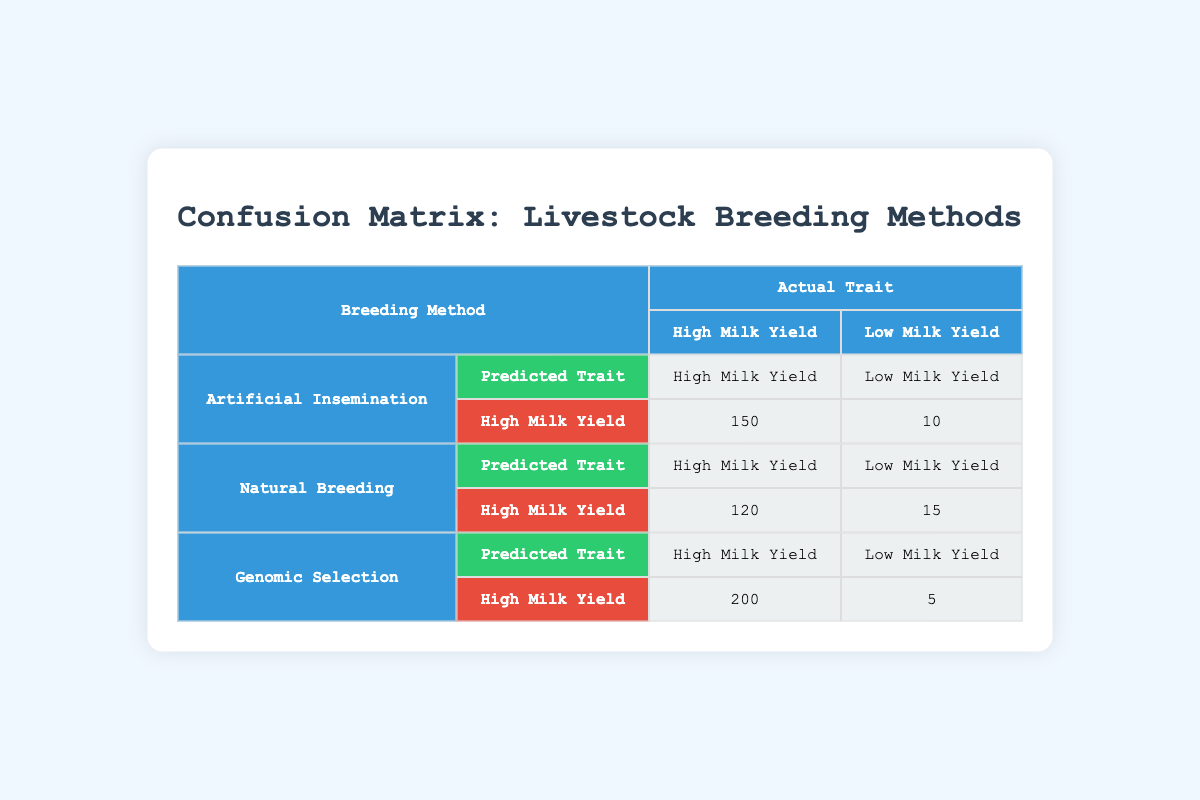What is the predicted trait count for High Milk Yield from Genomic Selection? From the table, under Genomic Selection with predicted trait as High Milk Yield, the count is given as 200.
Answer: 200 How many actual Low Milk Yield traits were predicted as High Milk Yield by Natural Breeding? The table shows that Natural Breeding predicted High Milk Yield for 15 actual Low Milk Yield cases.
Answer: 15 What is the total count of predicted High Milk Yield traits across all breeding methods? Adding the predicted High Milk Yield counts from all methods gives: 150 (AI) + 120 (Natural Breeding) + 200 (Genomic Selection) = 470.
Answer: 470 Is it true that Artificial Insemination had more Low Milk Yield predictions than Natural Breeding? Looking at the table, Artificial Insemination predicted Low Milk Yield 10 times while Natural Breeding predicted it 15 times; thus, it is false.
Answer: No How many cases of actual High Milk Yield were misclassified as Low Milk Yield across all breeding methods? The misclassifications are: 5 (AI) + 8 (Natural Breeding) + 2 (Genomic Selection) = 15 total cases.
Answer: 15 Which breeding method had the highest count of correct predictions for High Milk Yield? The table indicates Genomic Selection had the highest count with 200 correct predictions for High Milk Yield.
Answer: Genomic Selection What is the ratio of correct to incorrect predictions for Artificial Insemination? Correct predictions: 150 (High Milk Yield); Incorrect predictions: 10 (predicted Low Milk Yield for actual High Milk Yield) + 5 (predicted High Milk Yield for actual Low Milk Yield) = 15. Thus, the ratio is 150:15, which simplifies to 10:1.
Answer: 10:1 Did any breeding method predict High Milk Yield traits with fewer than 10 incorrect predictions? Reviewing the counts: Artificial Insemination had 15 incorrect predictions, Natural Breeding had 15, but Genomic Selection had only 5 incorrect predictions. This means yes, Genomic Selection is one method that fits this.
Answer: Yes 